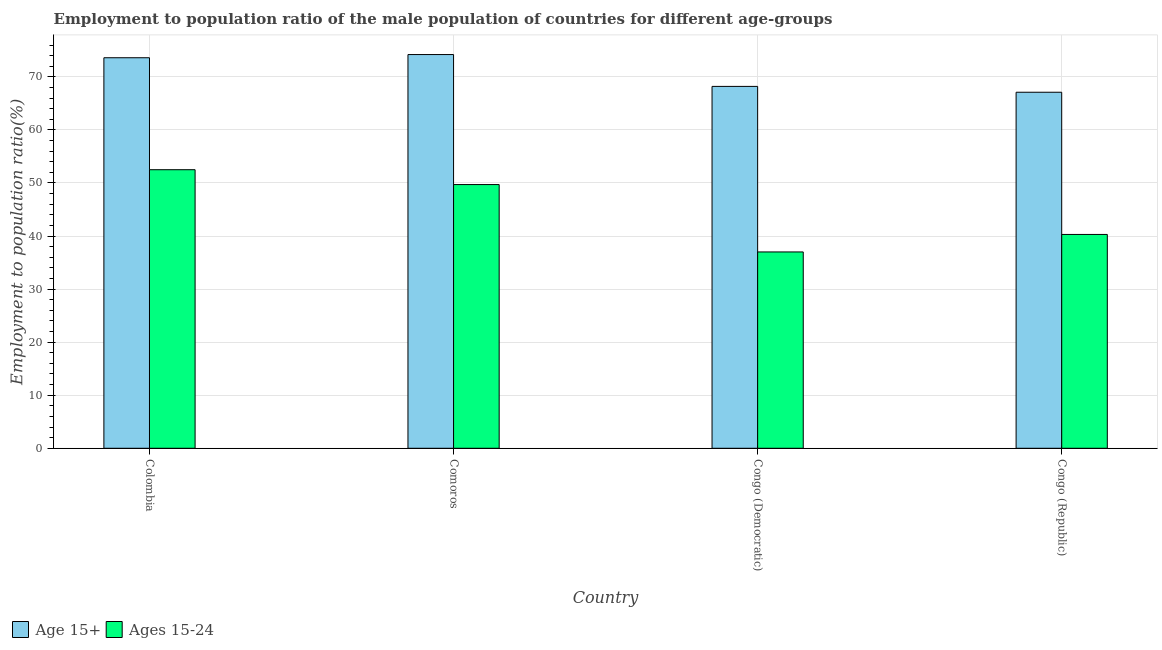Are the number of bars per tick equal to the number of legend labels?
Offer a very short reply. Yes. How many bars are there on the 3rd tick from the right?
Make the answer very short. 2. What is the label of the 3rd group of bars from the left?
Make the answer very short. Congo (Democratic). What is the employment to population ratio(age 15+) in Congo (Republic)?
Offer a very short reply. 67.1. Across all countries, what is the maximum employment to population ratio(age 15+)?
Give a very brief answer. 74.2. In which country was the employment to population ratio(age 15+) maximum?
Ensure brevity in your answer.  Comoros. In which country was the employment to population ratio(age 15-24) minimum?
Your answer should be very brief. Congo (Democratic). What is the total employment to population ratio(age 15-24) in the graph?
Your answer should be very brief. 179.5. What is the difference between the employment to population ratio(age 15-24) in Comoros and that in Congo (Democratic)?
Make the answer very short. 12.7. What is the difference between the employment to population ratio(age 15-24) in Congo (Republic) and the employment to population ratio(age 15+) in Congo (Democratic)?
Give a very brief answer. -27.9. What is the average employment to population ratio(age 15+) per country?
Offer a very short reply. 70.77. What is the difference between the employment to population ratio(age 15-24) and employment to population ratio(age 15+) in Congo (Democratic)?
Provide a succinct answer. -31.2. What is the ratio of the employment to population ratio(age 15-24) in Colombia to that in Congo (Democratic)?
Keep it short and to the point. 1.42. What is the difference between the highest and the second highest employment to population ratio(age 15+)?
Ensure brevity in your answer.  0.6. What is the difference between the highest and the lowest employment to population ratio(age 15+)?
Keep it short and to the point. 7.1. What does the 1st bar from the left in Congo (Democratic) represents?
Ensure brevity in your answer.  Age 15+. What does the 2nd bar from the right in Colombia represents?
Give a very brief answer. Age 15+. Are all the bars in the graph horizontal?
Offer a terse response. No. How many countries are there in the graph?
Provide a succinct answer. 4. What is the difference between two consecutive major ticks on the Y-axis?
Make the answer very short. 10. How many legend labels are there?
Keep it short and to the point. 2. What is the title of the graph?
Provide a short and direct response. Employment to population ratio of the male population of countries for different age-groups. What is the Employment to population ratio(%) of Age 15+ in Colombia?
Offer a terse response. 73.6. What is the Employment to population ratio(%) in Ages 15-24 in Colombia?
Make the answer very short. 52.5. What is the Employment to population ratio(%) in Age 15+ in Comoros?
Give a very brief answer. 74.2. What is the Employment to population ratio(%) of Ages 15-24 in Comoros?
Offer a terse response. 49.7. What is the Employment to population ratio(%) in Age 15+ in Congo (Democratic)?
Your answer should be very brief. 68.2. What is the Employment to population ratio(%) of Age 15+ in Congo (Republic)?
Offer a terse response. 67.1. What is the Employment to population ratio(%) of Ages 15-24 in Congo (Republic)?
Provide a succinct answer. 40.3. Across all countries, what is the maximum Employment to population ratio(%) in Age 15+?
Keep it short and to the point. 74.2. Across all countries, what is the maximum Employment to population ratio(%) in Ages 15-24?
Provide a succinct answer. 52.5. Across all countries, what is the minimum Employment to population ratio(%) in Age 15+?
Provide a short and direct response. 67.1. Across all countries, what is the minimum Employment to population ratio(%) of Ages 15-24?
Ensure brevity in your answer.  37. What is the total Employment to population ratio(%) in Age 15+ in the graph?
Give a very brief answer. 283.1. What is the total Employment to population ratio(%) in Ages 15-24 in the graph?
Ensure brevity in your answer.  179.5. What is the difference between the Employment to population ratio(%) of Ages 15-24 in Colombia and that in Comoros?
Ensure brevity in your answer.  2.8. What is the difference between the Employment to population ratio(%) of Age 15+ in Colombia and that in Congo (Republic)?
Ensure brevity in your answer.  6.5. What is the difference between the Employment to population ratio(%) in Age 15+ in Comoros and that in Congo (Democratic)?
Your answer should be very brief. 6. What is the difference between the Employment to population ratio(%) in Ages 15-24 in Comoros and that in Congo (Democratic)?
Ensure brevity in your answer.  12.7. What is the difference between the Employment to population ratio(%) of Ages 15-24 in Comoros and that in Congo (Republic)?
Ensure brevity in your answer.  9.4. What is the difference between the Employment to population ratio(%) of Age 15+ in Congo (Democratic) and that in Congo (Republic)?
Your answer should be very brief. 1.1. What is the difference between the Employment to population ratio(%) of Ages 15-24 in Congo (Democratic) and that in Congo (Republic)?
Provide a short and direct response. -3.3. What is the difference between the Employment to population ratio(%) of Age 15+ in Colombia and the Employment to population ratio(%) of Ages 15-24 in Comoros?
Your answer should be very brief. 23.9. What is the difference between the Employment to population ratio(%) of Age 15+ in Colombia and the Employment to population ratio(%) of Ages 15-24 in Congo (Democratic)?
Ensure brevity in your answer.  36.6. What is the difference between the Employment to population ratio(%) of Age 15+ in Colombia and the Employment to population ratio(%) of Ages 15-24 in Congo (Republic)?
Give a very brief answer. 33.3. What is the difference between the Employment to population ratio(%) of Age 15+ in Comoros and the Employment to population ratio(%) of Ages 15-24 in Congo (Democratic)?
Provide a succinct answer. 37.2. What is the difference between the Employment to population ratio(%) in Age 15+ in Comoros and the Employment to population ratio(%) in Ages 15-24 in Congo (Republic)?
Your answer should be very brief. 33.9. What is the difference between the Employment to population ratio(%) in Age 15+ in Congo (Democratic) and the Employment to population ratio(%) in Ages 15-24 in Congo (Republic)?
Offer a terse response. 27.9. What is the average Employment to population ratio(%) of Age 15+ per country?
Keep it short and to the point. 70.78. What is the average Employment to population ratio(%) in Ages 15-24 per country?
Ensure brevity in your answer.  44.88. What is the difference between the Employment to population ratio(%) in Age 15+ and Employment to population ratio(%) in Ages 15-24 in Colombia?
Provide a short and direct response. 21.1. What is the difference between the Employment to population ratio(%) in Age 15+ and Employment to population ratio(%) in Ages 15-24 in Congo (Democratic)?
Make the answer very short. 31.2. What is the difference between the Employment to population ratio(%) in Age 15+ and Employment to population ratio(%) in Ages 15-24 in Congo (Republic)?
Ensure brevity in your answer.  26.8. What is the ratio of the Employment to population ratio(%) in Age 15+ in Colombia to that in Comoros?
Make the answer very short. 0.99. What is the ratio of the Employment to population ratio(%) in Ages 15-24 in Colombia to that in Comoros?
Your answer should be very brief. 1.06. What is the ratio of the Employment to population ratio(%) in Age 15+ in Colombia to that in Congo (Democratic)?
Offer a very short reply. 1.08. What is the ratio of the Employment to population ratio(%) of Ages 15-24 in Colombia to that in Congo (Democratic)?
Your answer should be compact. 1.42. What is the ratio of the Employment to population ratio(%) of Age 15+ in Colombia to that in Congo (Republic)?
Make the answer very short. 1.1. What is the ratio of the Employment to population ratio(%) of Ages 15-24 in Colombia to that in Congo (Republic)?
Provide a succinct answer. 1.3. What is the ratio of the Employment to population ratio(%) in Age 15+ in Comoros to that in Congo (Democratic)?
Your answer should be very brief. 1.09. What is the ratio of the Employment to population ratio(%) in Ages 15-24 in Comoros to that in Congo (Democratic)?
Keep it short and to the point. 1.34. What is the ratio of the Employment to population ratio(%) in Age 15+ in Comoros to that in Congo (Republic)?
Offer a terse response. 1.11. What is the ratio of the Employment to population ratio(%) in Ages 15-24 in Comoros to that in Congo (Republic)?
Provide a short and direct response. 1.23. What is the ratio of the Employment to population ratio(%) in Age 15+ in Congo (Democratic) to that in Congo (Republic)?
Ensure brevity in your answer.  1.02. What is the ratio of the Employment to population ratio(%) of Ages 15-24 in Congo (Democratic) to that in Congo (Republic)?
Offer a very short reply. 0.92. What is the difference between the highest and the second highest Employment to population ratio(%) in Age 15+?
Keep it short and to the point. 0.6. What is the difference between the highest and the second highest Employment to population ratio(%) in Ages 15-24?
Keep it short and to the point. 2.8. What is the difference between the highest and the lowest Employment to population ratio(%) in Ages 15-24?
Provide a succinct answer. 15.5. 